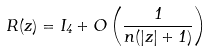<formula> <loc_0><loc_0><loc_500><loc_500>R ( z ) = I _ { 4 } + O \left ( \frac { 1 } { n ( | z | + 1 ) } \right )</formula> 